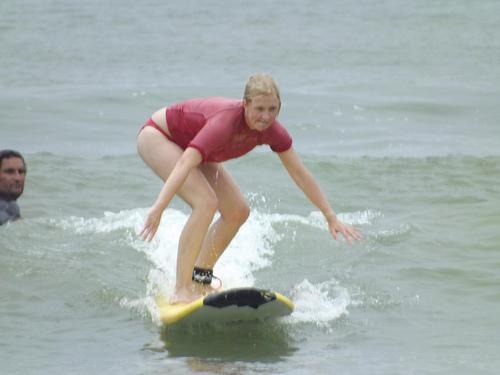How many people are there?
Give a very brief answer. 2. 